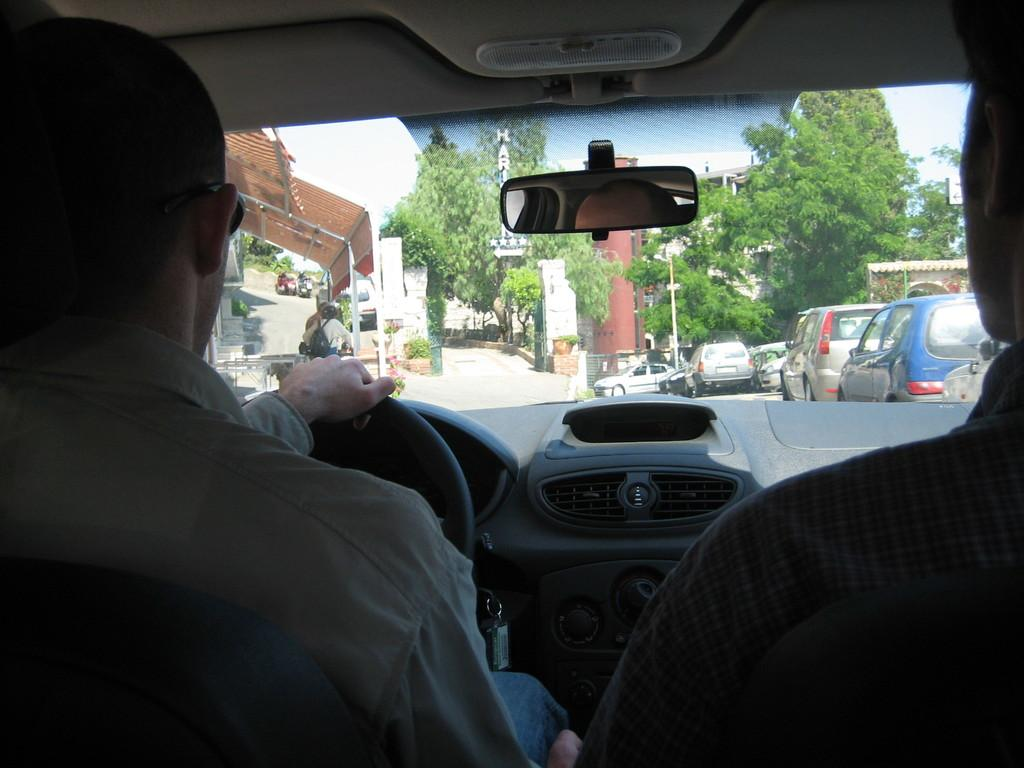What are the two men in the image doing? The two men are sitting in a car. What is the status of the car in the image? The car is in motion. What can be seen through the car window? Trees, vehicles, and a person riding a vehicle are visible through the car window. What is present in the image that might indicate a boundary or entrance? There is a gate in the image. What is the taste of the ice cream that the woman is holding in the image? There is no woman or ice cream present in the image. 